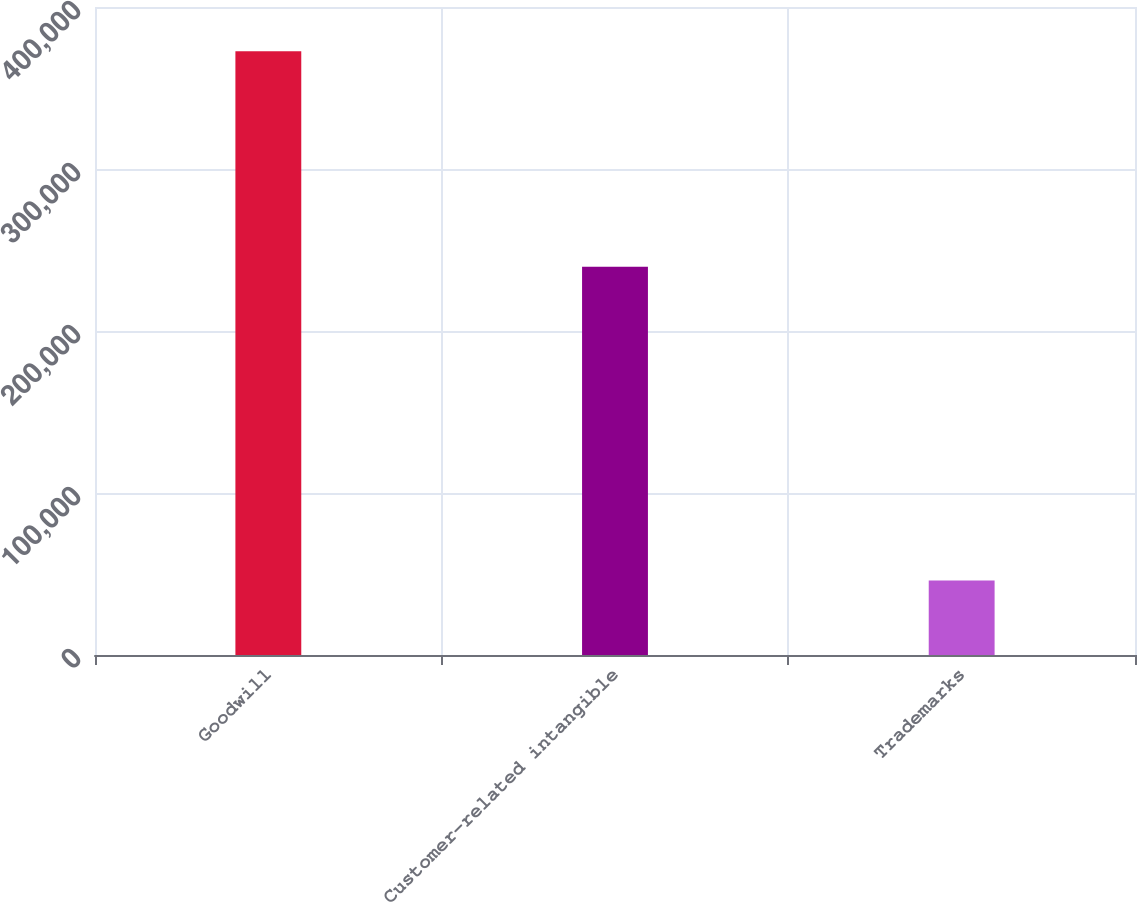Convert chart. <chart><loc_0><loc_0><loc_500><loc_500><bar_chart><fcel>Goodwill<fcel>Customer-related intangible<fcel>Trademarks<nl><fcel>372744<fcel>239637<fcel>45983<nl></chart> 